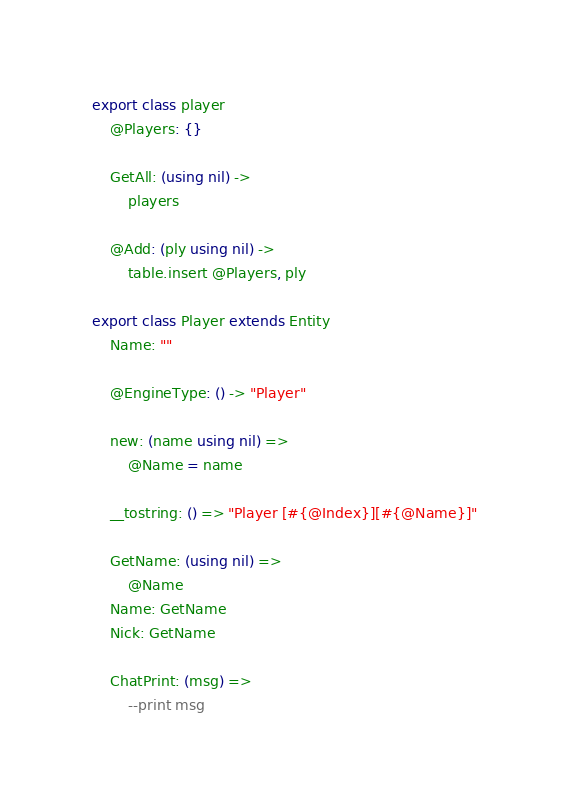<code> <loc_0><loc_0><loc_500><loc_500><_MoonScript_>export class player
	@Players: {}

	GetAll: (using nil) ->
		players

	@Add: (ply using nil) ->
		table.insert @Players, ply

export class Player extends Entity
	Name: ""

	@EngineType: () -> "Player"

	new: (name using nil) =>
		@Name = name

	__tostring: () => "Player [#{@Index}][#{@Name}]"

	GetName: (using nil) =>
		@Name
	Name: GetName
	Nick: GetName

	ChatPrint: (msg) =>
		--print msg
</code> 